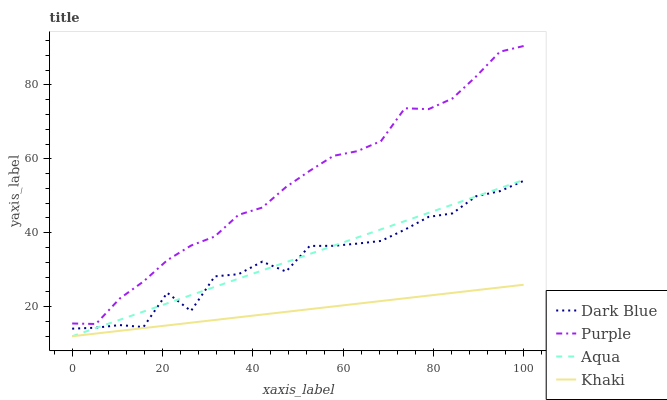Does Khaki have the minimum area under the curve?
Answer yes or no. Yes. Does Purple have the maximum area under the curve?
Answer yes or no. Yes. Does Dark Blue have the minimum area under the curve?
Answer yes or no. No. Does Dark Blue have the maximum area under the curve?
Answer yes or no. No. Is Khaki the smoothest?
Answer yes or no. Yes. Is Dark Blue the roughest?
Answer yes or no. Yes. Is Dark Blue the smoothest?
Answer yes or no. No. Is Khaki the roughest?
Answer yes or no. No. Does Khaki have the lowest value?
Answer yes or no. Yes. Does Dark Blue have the lowest value?
Answer yes or no. No. Does Purple have the highest value?
Answer yes or no. Yes. Does Dark Blue have the highest value?
Answer yes or no. No. Is Aqua less than Purple?
Answer yes or no. Yes. Is Dark Blue greater than Khaki?
Answer yes or no. Yes. Does Khaki intersect Aqua?
Answer yes or no. Yes. Is Khaki less than Aqua?
Answer yes or no. No. Is Khaki greater than Aqua?
Answer yes or no. No. Does Aqua intersect Purple?
Answer yes or no. No. 